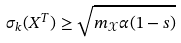Convert formula to latex. <formula><loc_0><loc_0><loc_500><loc_500>\sigma _ { k } ( X ^ { T } ) \geq \sqrt { m _ { \mathcal { X } } \alpha ( 1 - s ) }</formula> 